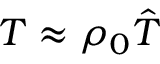<formula> <loc_0><loc_0><loc_500><loc_500>T \approx \rho _ { 0 } { \hat { T } }</formula> 